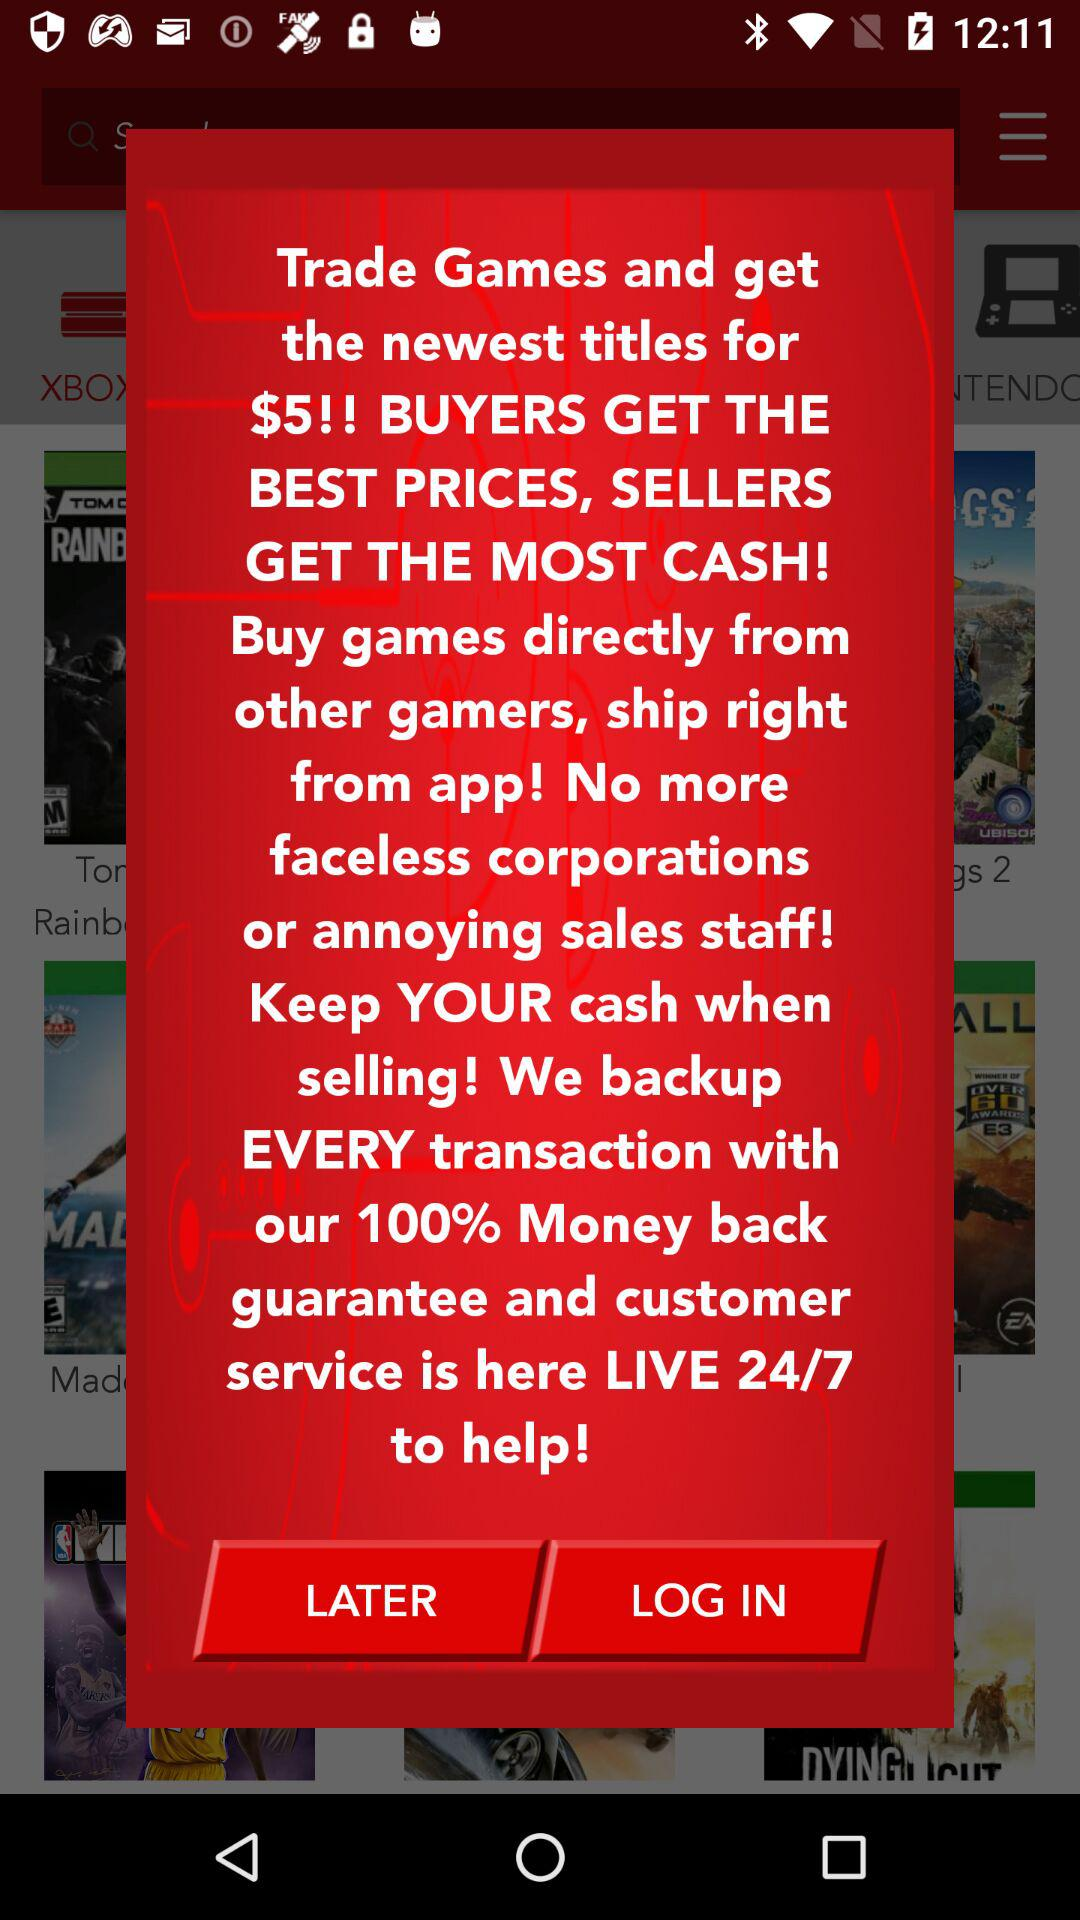How can we contact customer service by phone?
When the provided information is insufficient, respond with <no answer>. <no answer> 